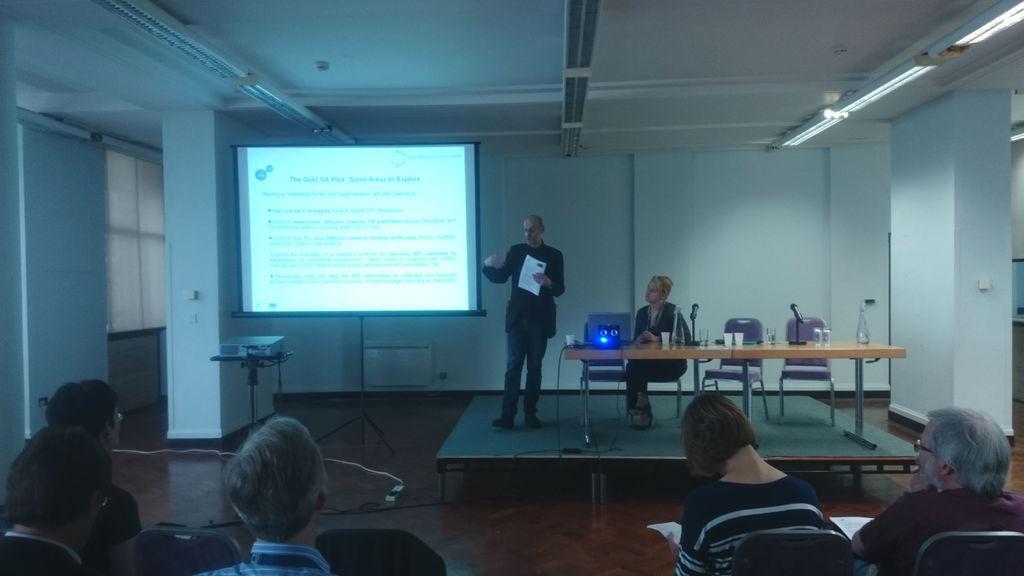In one or two sentences, can you explain what this image depicts? in this picture we can see a man speaking on the dais, and there is a woman staring at the man. There is a table and couple of chairs, there is also a microphone here. There are group of people sitting and listening to the man and there is a projector screen and a projector. 